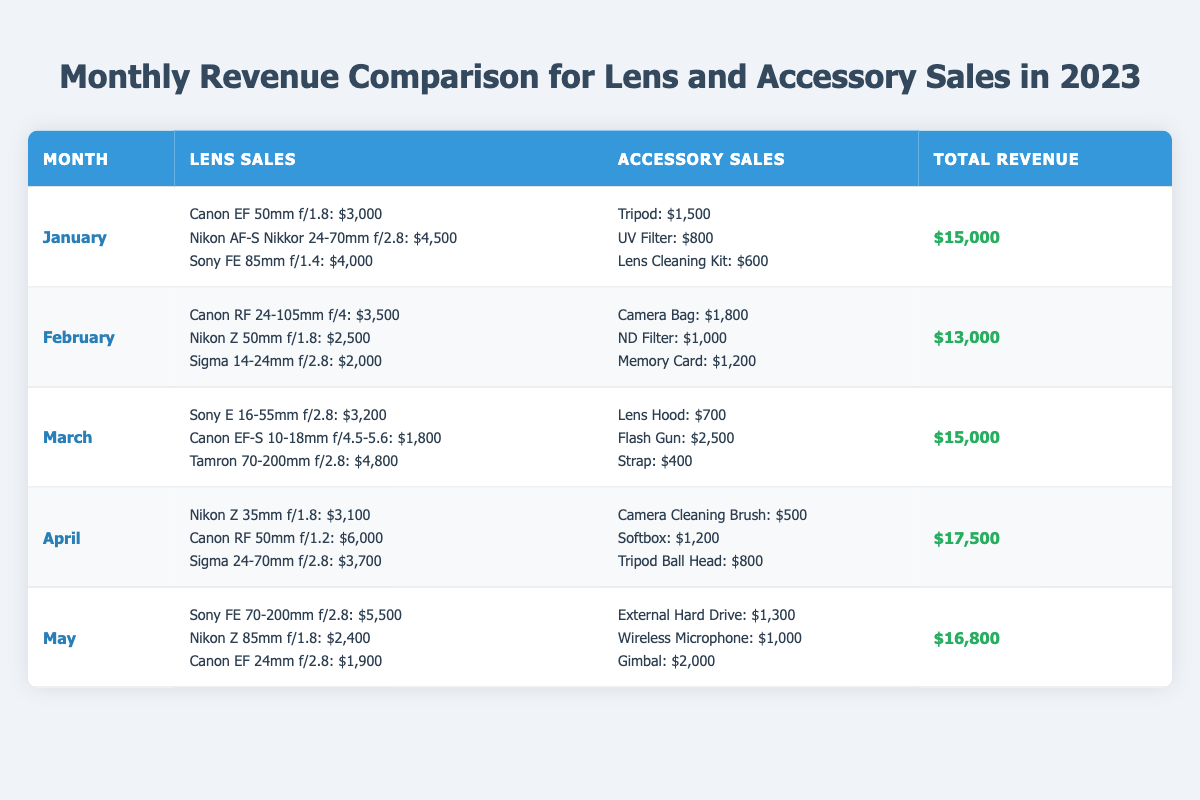What was the total revenue in April? The total revenue for April is listed in the table under the total revenue column for that month. It shows $17,500 as the total revenue for April.
Answer: $17,500 Which lens had the highest sales in May? By looking at the lens sales for May in the table, the Sony FE 70-200mm f/2.8 shows the highest sales value at $5,500 compared to the other lenses.
Answer: Sony FE 70-200mm f/2.8 What is the total revenue for the first quarter (January to March) combined? To find the total revenue for the first quarter, add the total revenue values for January ($15,000), February ($13,000), and March ($15,000). The sum is $15,000 + $13,000 + $15,000 = $43,000.
Answer: $43,000 Did accessory sales in March exceed lens sales? The total accessory sales for March sum to $3,600 (Lens Hood: $700 + Flash Gun: $2,500 + Strap: $400) and lens sales sum to $9,800 (Sony E 16-55mm f/2.8: $3,200 + Canon EF-S 10-18mm f/4.5-5.6: $1,800 + Tamron 70-200mm f/2.8: $4,800). Since $3,600 is less than $9,800, accessory sales did not exceed lens sales.
Answer: No What is the average revenue across the five months listed? To find the average revenue, sum the total revenues for all five months: $15,000 + $13,000 + $15,000 + $17,500 + $16,800 = $77,300. Then divide by the number of months (5), which gives $77,300 / 5 = $15,460.
Answer: $15,460 Was there a month where total revenue exceeded $17,000? By checking the total revenue values in the table, only April ($17,500) and May ($16,800) are close to or above $17,000; thus, only April exceeds that amount. Therefore, there was indeed a month (April) where total revenue exceeded $17,000.
Answer: Yes 